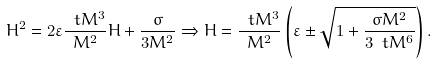Convert formula to latex. <formula><loc_0><loc_0><loc_500><loc_500>H ^ { 2 } = 2 \varepsilon \frac { \ t M ^ { 3 } } { M ^ { 2 } } H + \frac { \sigma } { 3 M ^ { 2 } } \Rightarrow H = \frac { \ t M ^ { 3 } } { M ^ { 2 } } \left ( \varepsilon \pm \sqrt { 1 + \frac { \sigma M ^ { 2 } } { 3 \ t M ^ { 6 } } } \right ) .</formula> 